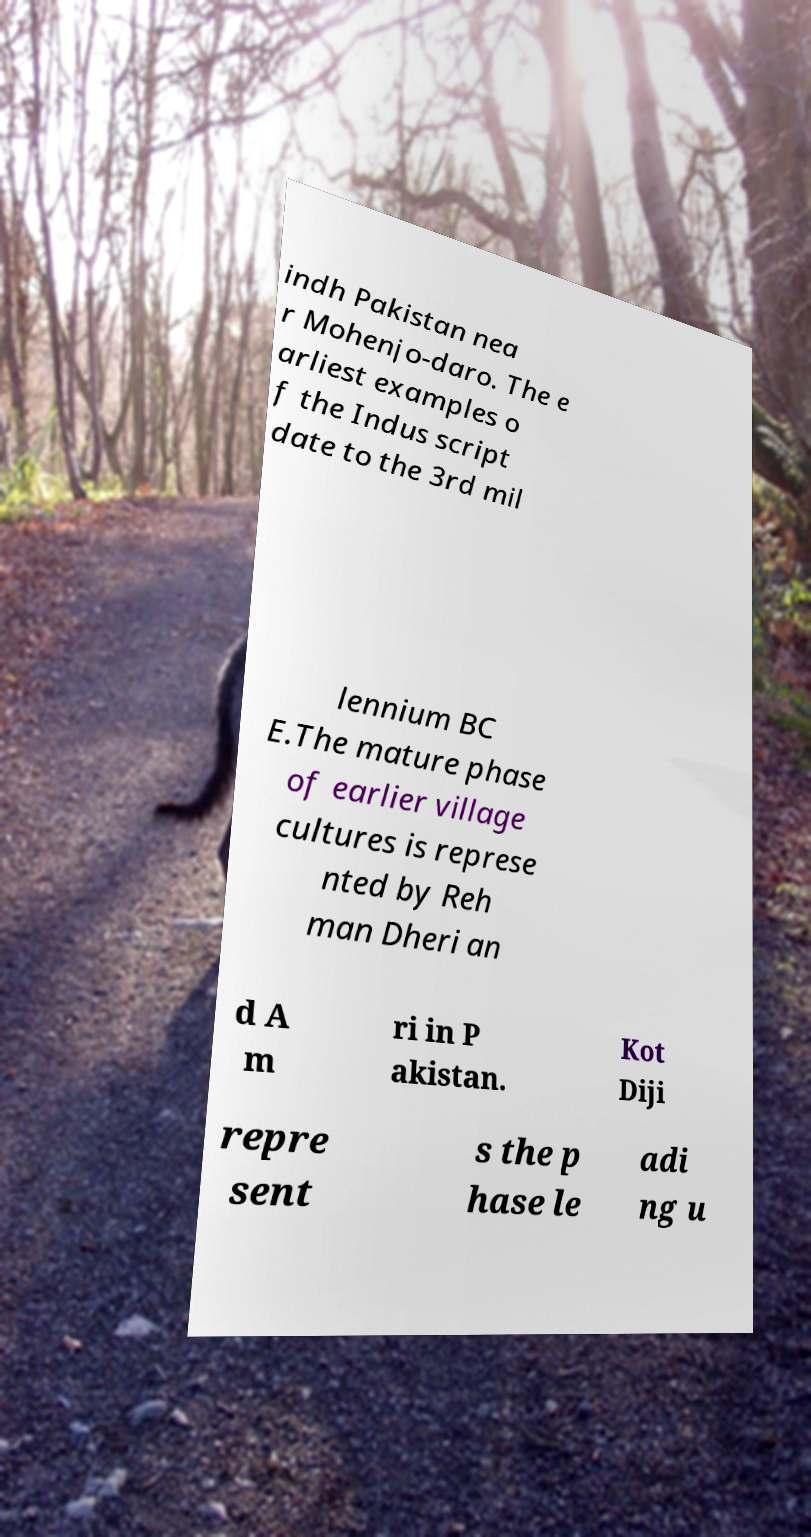Could you assist in decoding the text presented in this image and type it out clearly? indh Pakistan nea r Mohenjo-daro. The e arliest examples o f the Indus script date to the 3rd mil lennium BC E.The mature phase of earlier village cultures is represe nted by Reh man Dheri an d A m ri in P akistan. Kot Diji repre sent s the p hase le adi ng u 